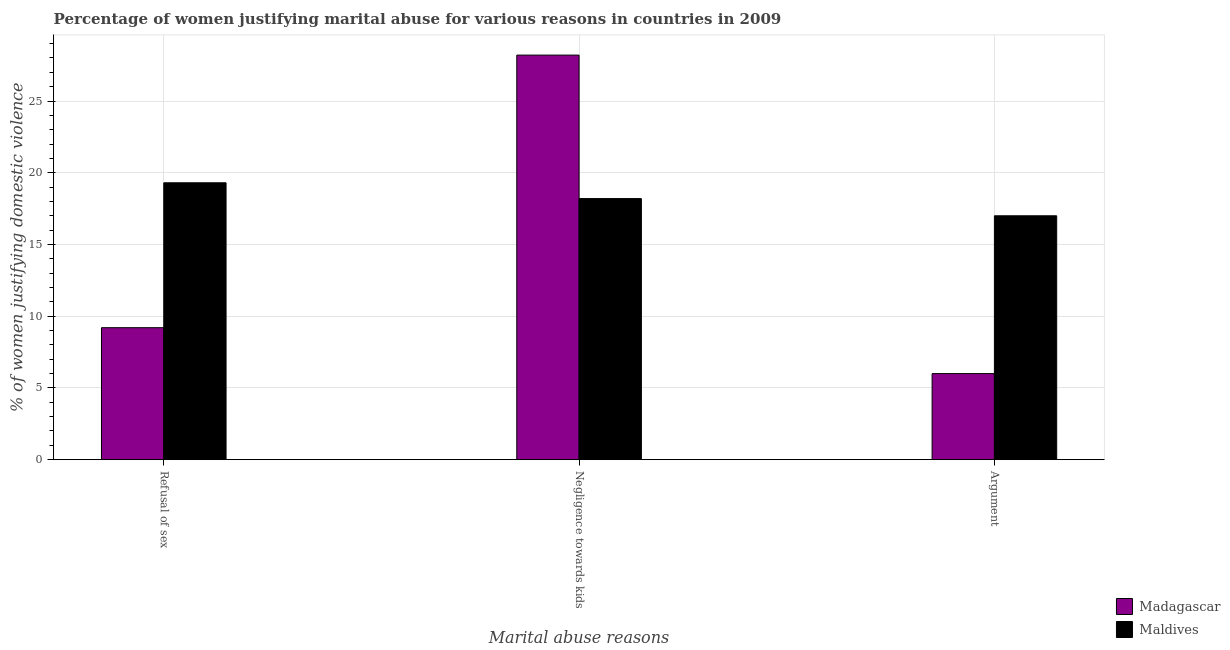Are the number of bars on each tick of the X-axis equal?
Your answer should be compact. Yes. How many bars are there on the 3rd tick from the right?
Provide a succinct answer. 2. What is the label of the 3rd group of bars from the left?
Keep it short and to the point. Argument. Across all countries, what is the maximum percentage of women justifying domestic violence due to negligence towards kids?
Provide a succinct answer. 28.2. Across all countries, what is the minimum percentage of women justifying domestic violence due to negligence towards kids?
Provide a short and direct response. 18.2. In which country was the percentage of women justifying domestic violence due to refusal of sex maximum?
Provide a short and direct response. Maldives. In which country was the percentage of women justifying domestic violence due to refusal of sex minimum?
Keep it short and to the point. Madagascar. What is the total percentage of women justifying domestic violence due to refusal of sex in the graph?
Provide a succinct answer. 28.5. What is the difference between the percentage of women justifying domestic violence due to refusal of sex in Maldives and that in Madagascar?
Your response must be concise. 10.1. What is the difference between the percentage of women justifying domestic violence due to refusal of sex in Maldives and the percentage of women justifying domestic violence due to negligence towards kids in Madagascar?
Keep it short and to the point. -8.9. What is the average percentage of women justifying domestic violence due to refusal of sex per country?
Your answer should be very brief. 14.25. What is the difference between the percentage of women justifying domestic violence due to refusal of sex and percentage of women justifying domestic violence due to arguments in Maldives?
Keep it short and to the point. 2.3. In how many countries, is the percentage of women justifying domestic violence due to arguments greater than 19 %?
Ensure brevity in your answer.  0. What is the ratio of the percentage of women justifying domestic violence due to arguments in Madagascar to that in Maldives?
Provide a succinct answer. 0.35. Is the percentage of women justifying domestic violence due to arguments in Maldives less than that in Madagascar?
Your answer should be compact. No. Is the difference between the percentage of women justifying domestic violence due to arguments in Madagascar and Maldives greater than the difference between the percentage of women justifying domestic violence due to refusal of sex in Madagascar and Maldives?
Make the answer very short. No. In how many countries, is the percentage of women justifying domestic violence due to refusal of sex greater than the average percentage of women justifying domestic violence due to refusal of sex taken over all countries?
Provide a succinct answer. 1. Is the sum of the percentage of women justifying domestic violence due to negligence towards kids in Madagascar and Maldives greater than the maximum percentage of women justifying domestic violence due to refusal of sex across all countries?
Your answer should be very brief. Yes. What does the 2nd bar from the left in Negligence towards kids represents?
Ensure brevity in your answer.  Maldives. What does the 1st bar from the right in Argument represents?
Give a very brief answer. Maldives. Is it the case that in every country, the sum of the percentage of women justifying domestic violence due to refusal of sex and percentage of women justifying domestic violence due to negligence towards kids is greater than the percentage of women justifying domestic violence due to arguments?
Offer a very short reply. Yes. How many countries are there in the graph?
Provide a succinct answer. 2. What is the difference between two consecutive major ticks on the Y-axis?
Provide a succinct answer. 5. Are the values on the major ticks of Y-axis written in scientific E-notation?
Give a very brief answer. No. Does the graph contain any zero values?
Your answer should be very brief. No. Where does the legend appear in the graph?
Your response must be concise. Bottom right. What is the title of the graph?
Offer a very short reply. Percentage of women justifying marital abuse for various reasons in countries in 2009. What is the label or title of the X-axis?
Your answer should be very brief. Marital abuse reasons. What is the label or title of the Y-axis?
Provide a short and direct response. % of women justifying domestic violence. What is the % of women justifying domestic violence of Madagascar in Refusal of sex?
Give a very brief answer. 9.2. What is the % of women justifying domestic violence in Maldives in Refusal of sex?
Provide a succinct answer. 19.3. What is the % of women justifying domestic violence of Madagascar in Negligence towards kids?
Your answer should be compact. 28.2. What is the % of women justifying domestic violence of Maldives in Negligence towards kids?
Provide a succinct answer. 18.2. What is the % of women justifying domestic violence in Maldives in Argument?
Your answer should be very brief. 17. Across all Marital abuse reasons, what is the maximum % of women justifying domestic violence of Madagascar?
Give a very brief answer. 28.2. Across all Marital abuse reasons, what is the maximum % of women justifying domestic violence in Maldives?
Offer a terse response. 19.3. Across all Marital abuse reasons, what is the minimum % of women justifying domestic violence in Maldives?
Your response must be concise. 17. What is the total % of women justifying domestic violence of Madagascar in the graph?
Your response must be concise. 43.4. What is the total % of women justifying domestic violence in Maldives in the graph?
Offer a very short reply. 54.5. What is the difference between the % of women justifying domestic violence of Madagascar in Refusal of sex and that in Negligence towards kids?
Your answer should be very brief. -19. What is the difference between the % of women justifying domestic violence in Maldives in Refusal of sex and that in Negligence towards kids?
Provide a short and direct response. 1.1. What is the difference between the % of women justifying domestic violence of Madagascar in Refusal of sex and that in Argument?
Your answer should be compact. 3.2. What is the difference between the % of women justifying domestic violence in Madagascar in Negligence towards kids and that in Argument?
Your response must be concise. 22.2. What is the difference between the % of women justifying domestic violence in Madagascar in Refusal of sex and the % of women justifying domestic violence in Maldives in Argument?
Keep it short and to the point. -7.8. What is the average % of women justifying domestic violence in Madagascar per Marital abuse reasons?
Give a very brief answer. 14.47. What is the average % of women justifying domestic violence of Maldives per Marital abuse reasons?
Make the answer very short. 18.17. What is the difference between the % of women justifying domestic violence of Madagascar and % of women justifying domestic violence of Maldives in Refusal of sex?
Your answer should be very brief. -10.1. What is the ratio of the % of women justifying domestic violence of Madagascar in Refusal of sex to that in Negligence towards kids?
Offer a very short reply. 0.33. What is the ratio of the % of women justifying domestic violence of Maldives in Refusal of sex to that in Negligence towards kids?
Provide a succinct answer. 1.06. What is the ratio of the % of women justifying domestic violence of Madagascar in Refusal of sex to that in Argument?
Your answer should be compact. 1.53. What is the ratio of the % of women justifying domestic violence in Maldives in Refusal of sex to that in Argument?
Keep it short and to the point. 1.14. What is the ratio of the % of women justifying domestic violence of Madagascar in Negligence towards kids to that in Argument?
Your response must be concise. 4.7. What is the ratio of the % of women justifying domestic violence of Maldives in Negligence towards kids to that in Argument?
Offer a very short reply. 1.07. What is the difference between the highest and the lowest % of women justifying domestic violence in Madagascar?
Offer a terse response. 22.2. What is the difference between the highest and the lowest % of women justifying domestic violence of Maldives?
Give a very brief answer. 2.3. 